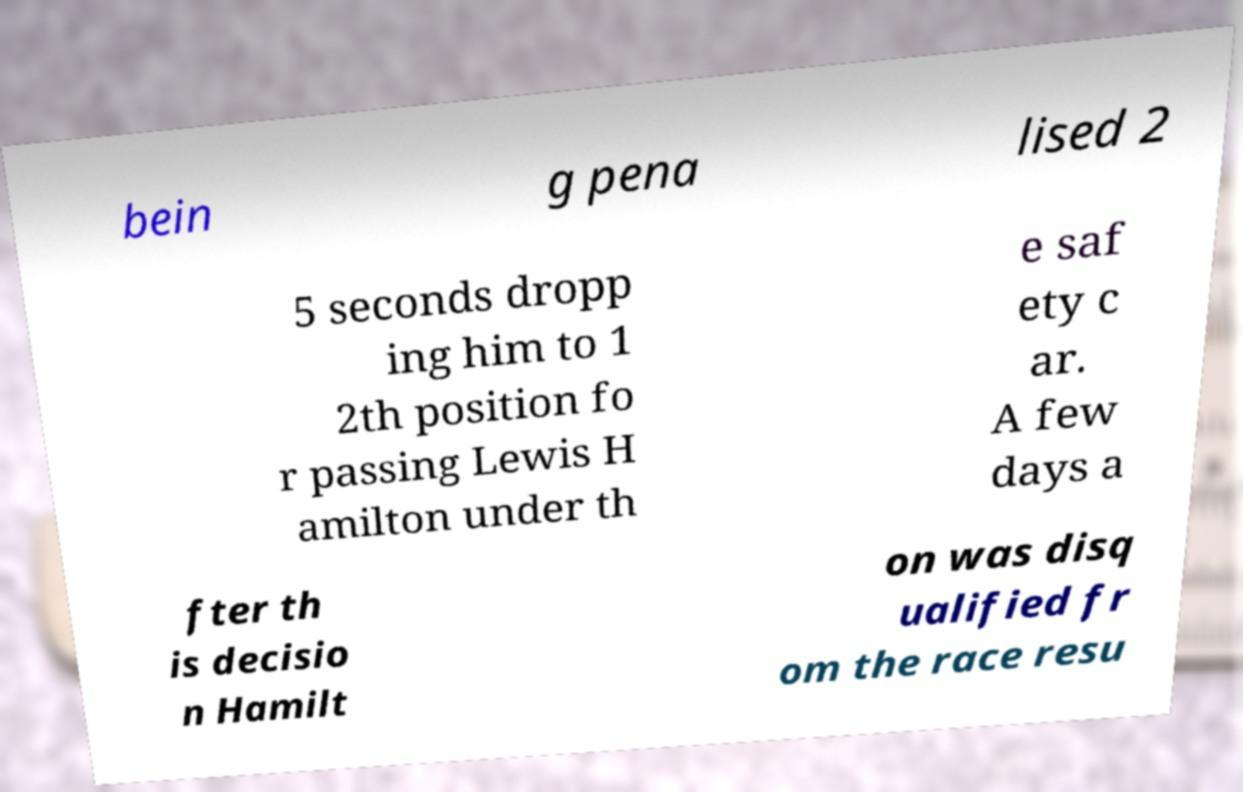What messages or text are displayed in this image? I need them in a readable, typed format. bein g pena lised 2 5 seconds dropp ing him to 1 2th position fo r passing Lewis H amilton under th e saf ety c ar. A few days a fter th is decisio n Hamilt on was disq ualified fr om the race resu 